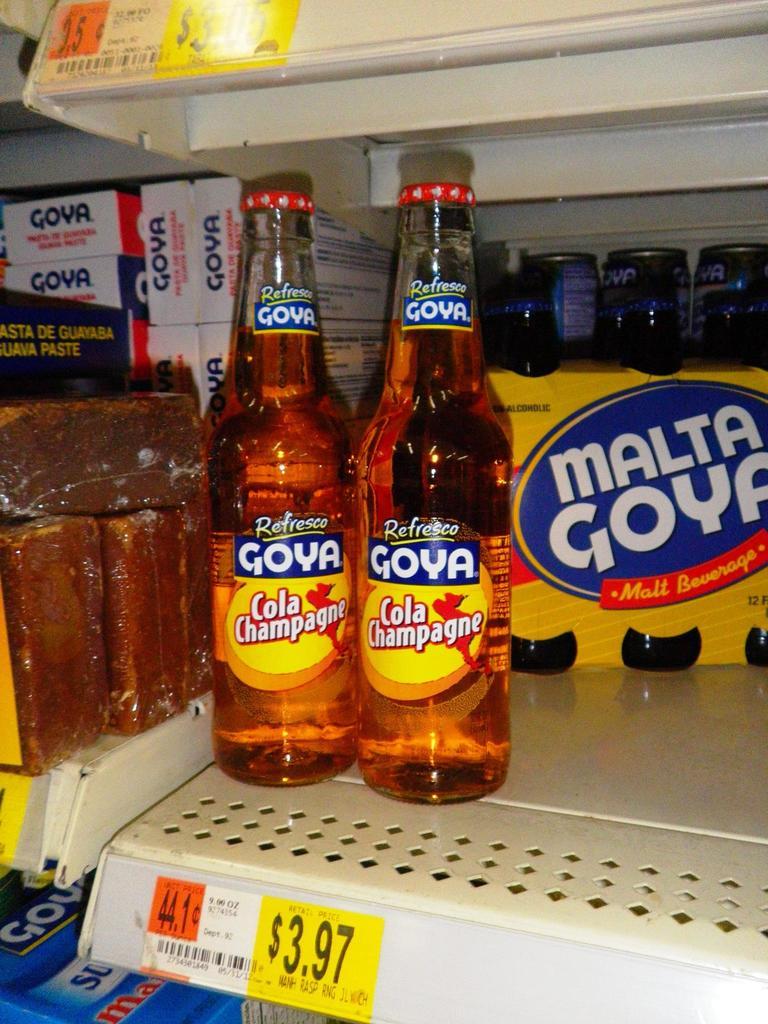How much is the goya?
Provide a succinct answer. $3.97. This some drink item?
Offer a terse response. Answering does not require reading text in the image. 